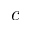Convert formula to latex. <formula><loc_0><loc_0><loc_500><loc_500>c</formula> 